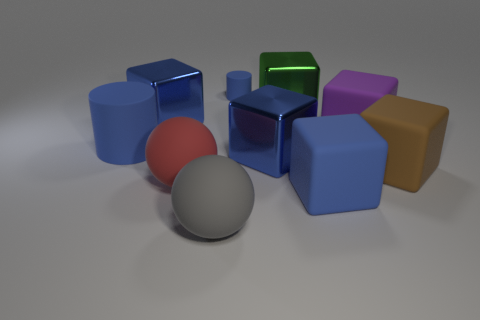Do the gray thing and the blue cube that is behind the large blue matte cylinder have the same material?
Provide a short and direct response. No. What material is the large thing that is both in front of the large red ball and to the right of the gray thing?
Ensure brevity in your answer.  Rubber. How many purple things are in front of the gray sphere?
Your response must be concise. 0. There is another big sphere that is made of the same material as the big red ball; what is its color?
Make the answer very short. Gray. Do the big gray rubber object and the red rubber thing have the same shape?
Offer a terse response. Yes. What number of blocks are right of the big red thing and behind the purple cube?
Keep it short and to the point. 1. What number of metallic objects are either large things or big blue cylinders?
Your answer should be very brief. 3. What size is the blue rubber thing that is in front of the metallic block in front of the purple block?
Provide a succinct answer. Large. There is a big cylinder that is the same color as the tiny matte cylinder; what material is it?
Provide a short and direct response. Rubber. There is a blue rubber cylinder that is in front of the cylinder that is behind the green shiny thing; is there a big blue metal cube that is behind it?
Your response must be concise. Yes. 